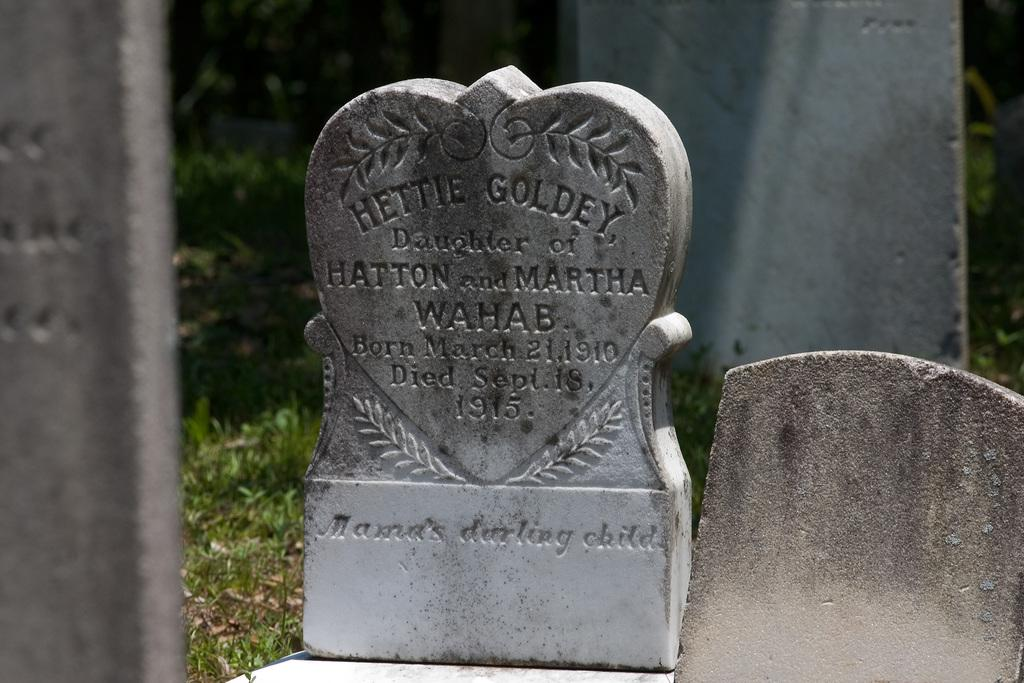What can be seen in the image that represents a memorial or grave marker? There is a tombstone in the image. What is written or engraved on the tombstone? Letters are engraved on the tombstone. What type of transport is depicted on the tombstone in the image? There is no transport depicted on the tombstone in the image; it only has engraved letters. 